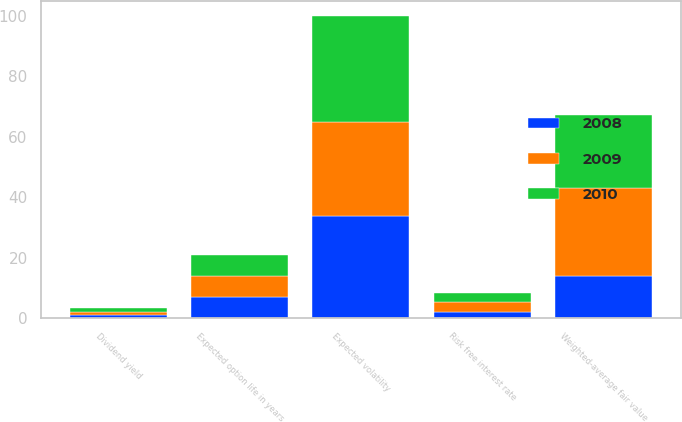Convert chart. <chart><loc_0><loc_0><loc_500><loc_500><stacked_bar_chart><ecel><fcel>Dividend yield<fcel>Expected volatility<fcel>Risk free interest rate<fcel>Expected option life in years<fcel>Weighted-average fair value<nl><fcel>2010<fcel>1.3<fcel>35<fcel>2.9<fcel>6.9<fcel>24.13<nl><fcel>2008<fcel>1.2<fcel>34<fcel>2.2<fcel>6.9<fcel>13.92<nl><fcel>2009<fcel>1<fcel>31<fcel>3.2<fcel>7<fcel>29.33<nl></chart> 